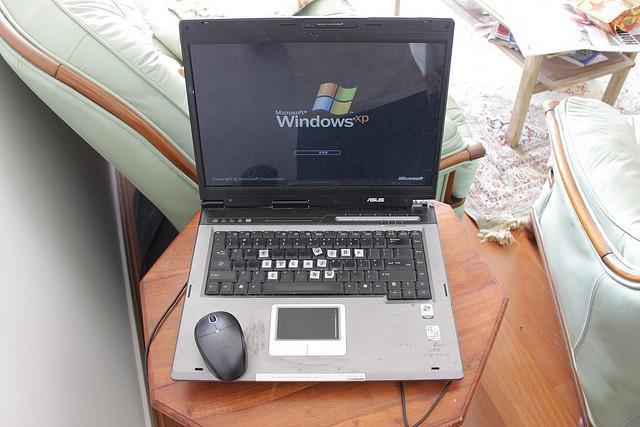How many people are in this photo?
Give a very brief answer. 0. 